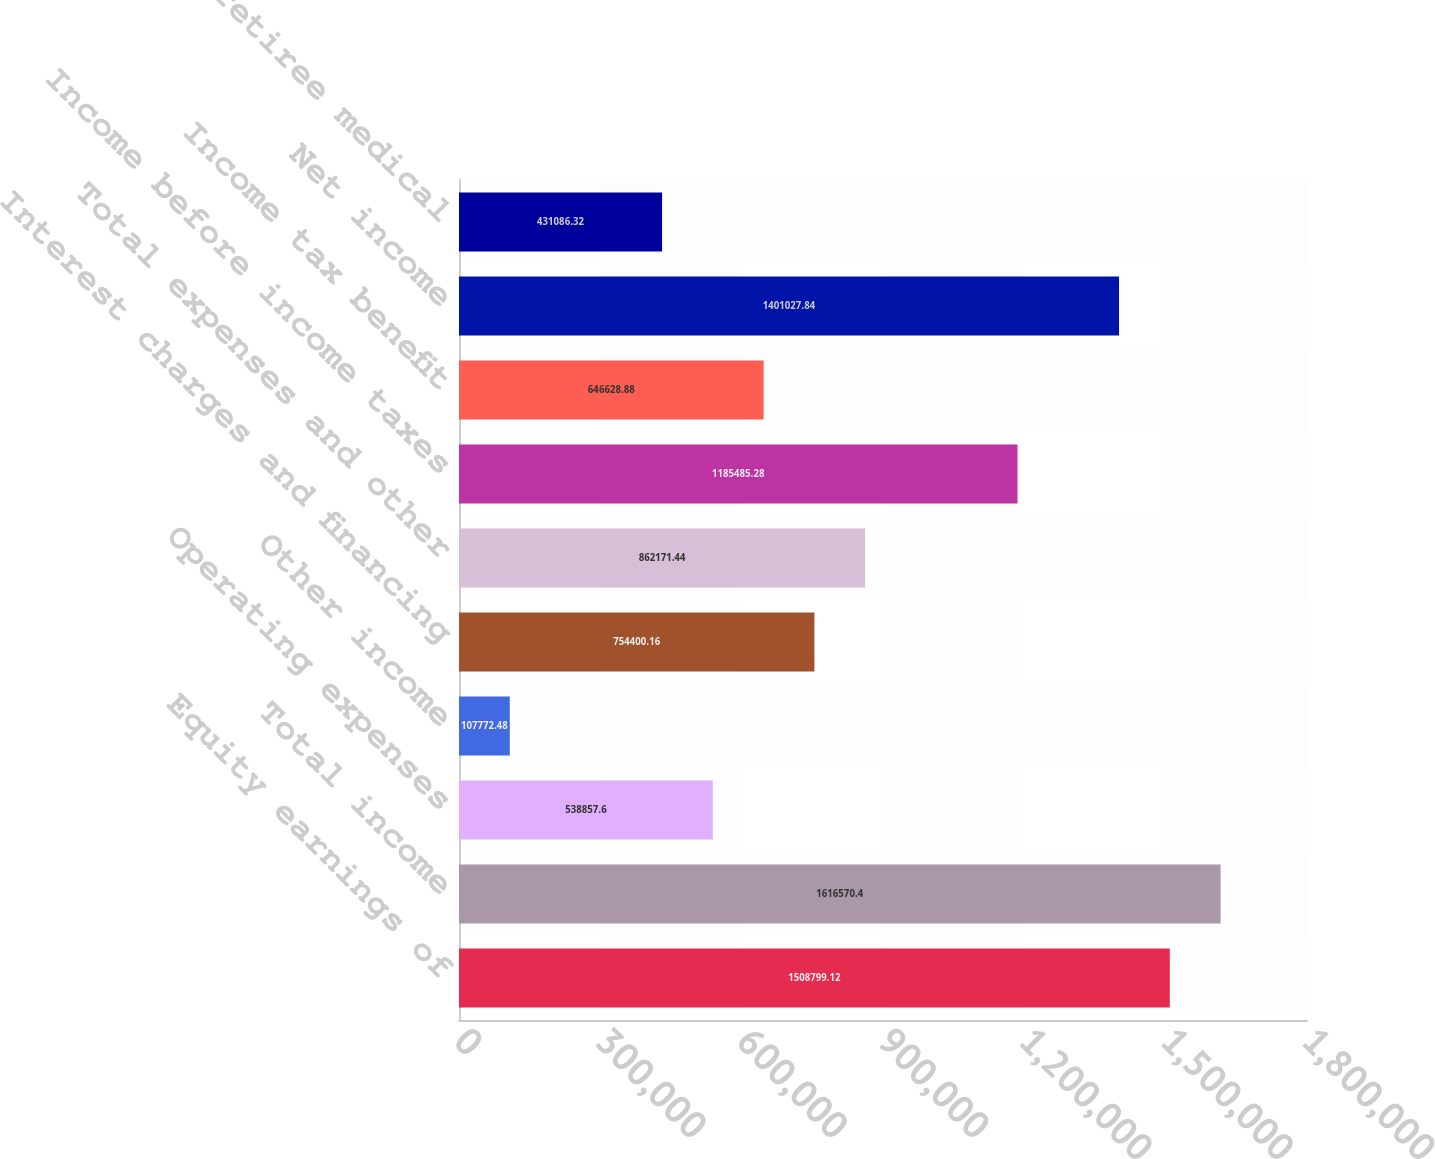Convert chart to OTSL. <chart><loc_0><loc_0><loc_500><loc_500><bar_chart><fcel>Equity earnings of<fcel>Total income<fcel>Operating expenses<fcel>Other income<fcel>Interest charges and financing<fcel>Total expenses and other<fcel>Income before income taxes<fcel>Income tax benefit<fcel>Net income<fcel>Pension and retiree medical<nl><fcel>1.5088e+06<fcel>1.61657e+06<fcel>538858<fcel>107772<fcel>754400<fcel>862171<fcel>1.18549e+06<fcel>646629<fcel>1.40103e+06<fcel>431086<nl></chart> 